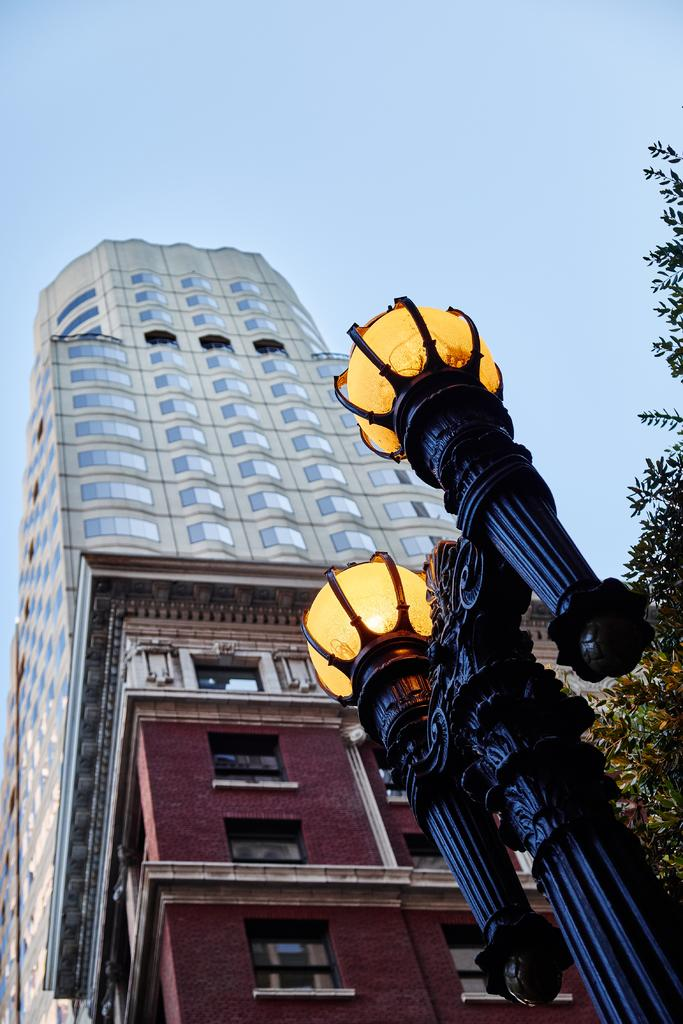What type of structure is the main subject of the image? There is a skyscraper in the image. Can you describe any other buildings in the image? Yes, there is another building in the image. What can be seen at the bottom right of the image? There is a street light at the bottom right of the image. What type of vegetation is on the right side of the image? There are trees on the right side of the image. What is visible at the top of the image? The sky is visible at the top of the image. What can be seen in the sky? Clouds are present in the sky. How many prisoners are visible in the image? There are no prisoners present in the image. What type of bomb is being dropped from the skyscraper in the image? There is no bomb present in the image; it is a skyscraper and other buildings. 